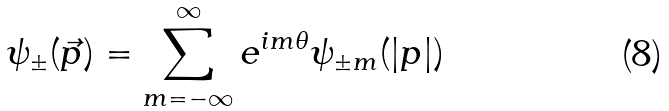Convert formula to latex. <formula><loc_0><loc_0><loc_500><loc_500>\psi _ { \pm } ( \vec { p } ) = \sum _ { m = - \infty } ^ { \infty } e ^ { i m \theta } \psi _ { \pm m } ( | p | )</formula> 